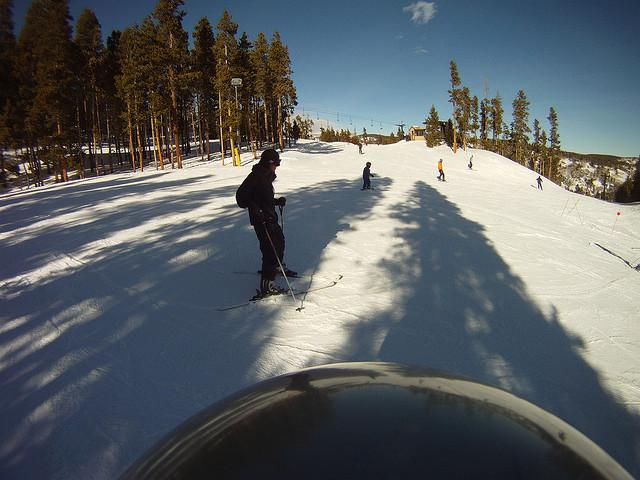What surrounds these people? Please explain your reasoning. mountains. Snow and mountains surround the skiers. 